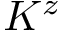Convert formula to latex. <formula><loc_0><loc_0><loc_500><loc_500>K ^ { z }</formula> 